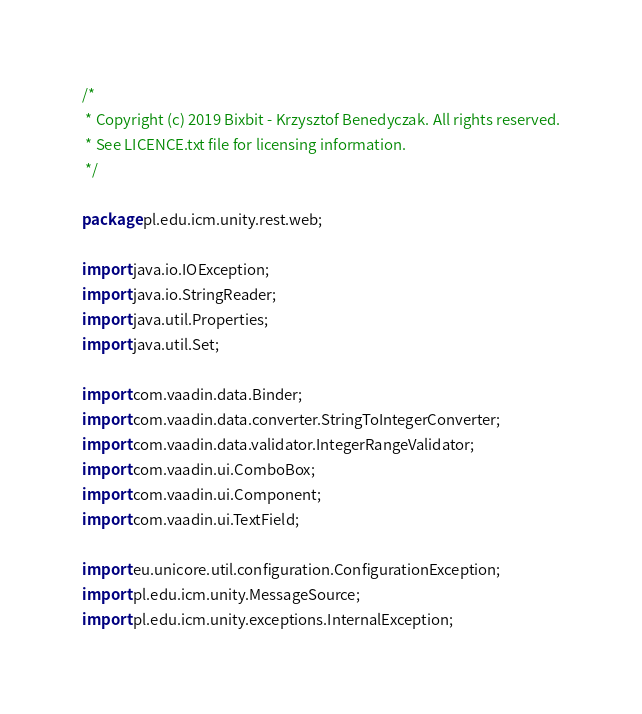Convert code to text. <code><loc_0><loc_0><loc_500><loc_500><_Java_>/*
 * Copyright (c) 2019 Bixbit - Krzysztof Benedyczak. All rights reserved.
 * See LICENCE.txt file for licensing information.
 */

package pl.edu.icm.unity.rest.web;

import java.io.IOException;
import java.io.StringReader;
import java.util.Properties;
import java.util.Set;

import com.vaadin.data.Binder;
import com.vaadin.data.converter.StringToIntegerConverter;
import com.vaadin.data.validator.IntegerRangeValidator;
import com.vaadin.ui.ComboBox;
import com.vaadin.ui.Component;
import com.vaadin.ui.TextField;

import eu.unicore.util.configuration.ConfigurationException;
import pl.edu.icm.unity.MessageSource;
import pl.edu.icm.unity.exceptions.InternalException;</code> 